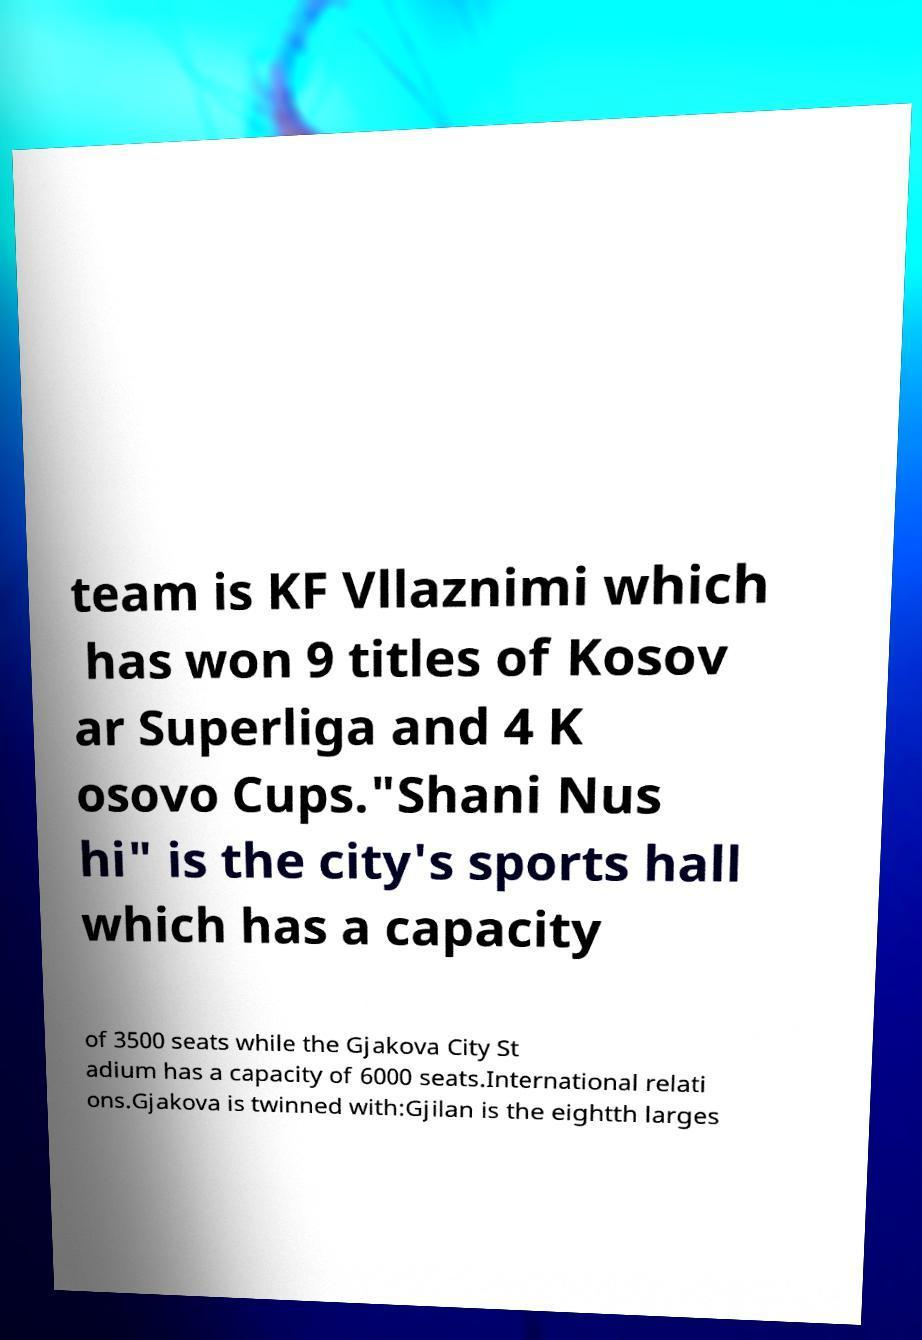Please identify and transcribe the text found in this image. team is KF Vllaznimi which has won 9 titles of Kosov ar Superliga and 4 K osovo Cups."Shani Nus hi" is the city's sports hall which has a capacity of 3500 seats while the Gjakova City St adium has a capacity of 6000 seats.International relati ons.Gjakova is twinned with:Gjilan is the eightth larges 